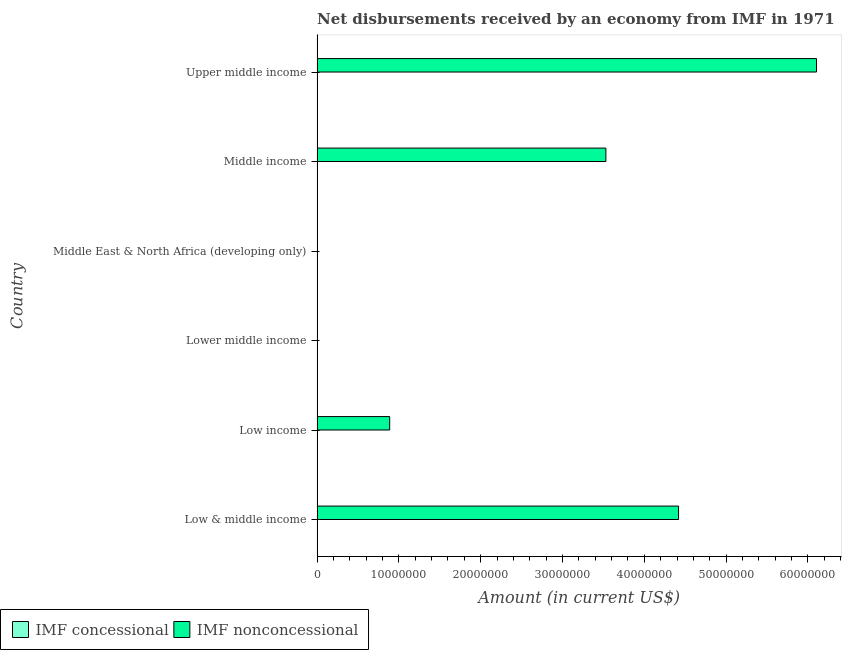Are the number of bars on each tick of the Y-axis equal?
Give a very brief answer. No. How many bars are there on the 3rd tick from the top?
Ensure brevity in your answer.  0. In how many cases, is the number of bars for a given country not equal to the number of legend labels?
Your answer should be compact. 6. What is the net non concessional disbursements from imf in Middle income?
Your response must be concise. 3.53e+07. Across all countries, what is the maximum net non concessional disbursements from imf?
Provide a short and direct response. 6.11e+07. Across all countries, what is the minimum net non concessional disbursements from imf?
Offer a terse response. 0. In which country was the net non concessional disbursements from imf maximum?
Provide a succinct answer. Upper middle income. What is the difference between the net non concessional disbursements from imf in Low & middle income and that in Upper middle income?
Offer a very short reply. -1.69e+07. What is the difference between the net non concessional disbursements from imf in Low & middle income and the net concessional disbursements from imf in Middle East & North Africa (developing only)?
Your answer should be very brief. 4.42e+07. In how many countries, is the net concessional disbursements from imf greater than 50000000 US$?
Ensure brevity in your answer.  0. What is the ratio of the net non concessional disbursements from imf in Low & middle income to that in Upper middle income?
Offer a terse response. 0.72. Is the net non concessional disbursements from imf in Middle income less than that in Upper middle income?
Make the answer very short. Yes. What is the difference between the highest and the second highest net non concessional disbursements from imf?
Your answer should be compact. 1.69e+07. What is the difference between the highest and the lowest net non concessional disbursements from imf?
Keep it short and to the point. 6.11e+07. In how many countries, is the net concessional disbursements from imf greater than the average net concessional disbursements from imf taken over all countries?
Your answer should be very brief. 0. Are all the bars in the graph horizontal?
Offer a terse response. Yes. What is the difference between two consecutive major ticks on the X-axis?
Provide a succinct answer. 1.00e+07. Are the values on the major ticks of X-axis written in scientific E-notation?
Make the answer very short. No. Does the graph contain any zero values?
Your answer should be very brief. Yes. How many legend labels are there?
Your answer should be compact. 2. What is the title of the graph?
Ensure brevity in your answer.  Net disbursements received by an economy from IMF in 1971. What is the label or title of the Y-axis?
Your answer should be very brief. Country. What is the Amount (in current US$) in IMF nonconcessional in Low & middle income?
Provide a short and direct response. 4.42e+07. What is the Amount (in current US$) in IMF nonconcessional in Low income?
Your answer should be compact. 8.88e+06. What is the Amount (in current US$) of IMF concessional in Lower middle income?
Your answer should be compact. 0. What is the Amount (in current US$) in IMF nonconcessional in Lower middle income?
Give a very brief answer. 0. What is the Amount (in current US$) of IMF concessional in Middle income?
Your answer should be very brief. 0. What is the Amount (in current US$) of IMF nonconcessional in Middle income?
Offer a terse response. 3.53e+07. What is the Amount (in current US$) of IMF nonconcessional in Upper middle income?
Give a very brief answer. 6.11e+07. Across all countries, what is the maximum Amount (in current US$) of IMF nonconcessional?
Provide a succinct answer. 6.11e+07. What is the total Amount (in current US$) of IMF nonconcessional in the graph?
Make the answer very short. 1.49e+08. What is the difference between the Amount (in current US$) in IMF nonconcessional in Low & middle income and that in Low income?
Ensure brevity in your answer.  3.53e+07. What is the difference between the Amount (in current US$) in IMF nonconcessional in Low & middle income and that in Middle income?
Your answer should be very brief. 8.88e+06. What is the difference between the Amount (in current US$) in IMF nonconcessional in Low & middle income and that in Upper middle income?
Provide a short and direct response. -1.69e+07. What is the difference between the Amount (in current US$) of IMF nonconcessional in Low income and that in Middle income?
Keep it short and to the point. -2.64e+07. What is the difference between the Amount (in current US$) in IMF nonconcessional in Low income and that in Upper middle income?
Provide a short and direct response. -5.22e+07. What is the difference between the Amount (in current US$) in IMF nonconcessional in Middle income and that in Upper middle income?
Ensure brevity in your answer.  -2.57e+07. What is the average Amount (in current US$) in IMF nonconcessional per country?
Keep it short and to the point. 2.49e+07. What is the ratio of the Amount (in current US$) in IMF nonconcessional in Low & middle income to that in Low income?
Provide a short and direct response. 4.98. What is the ratio of the Amount (in current US$) in IMF nonconcessional in Low & middle income to that in Middle income?
Offer a terse response. 1.25. What is the ratio of the Amount (in current US$) in IMF nonconcessional in Low & middle income to that in Upper middle income?
Make the answer very short. 0.72. What is the ratio of the Amount (in current US$) in IMF nonconcessional in Low income to that in Middle income?
Provide a short and direct response. 0.25. What is the ratio of the Amount (in current US$) of IMF nonconcessional in Low income to that in Upper middle income?
Make the answer very short. 0.15. What is the ratio of the Amount (in current US$) in IMF nonconcessional in Middle income to that in Upper middle income?
Your response must be concise. 0.58. What is the difference between the highest and the second highest Amount (in current US$) in IMF nonconcessional?
Offer a very short reply. 1.69e+07. What is the difference between the highest and the lowest Amount (in current US$) of IMF nonconcessional?
Your answer should be compact. 6.11e+07. 